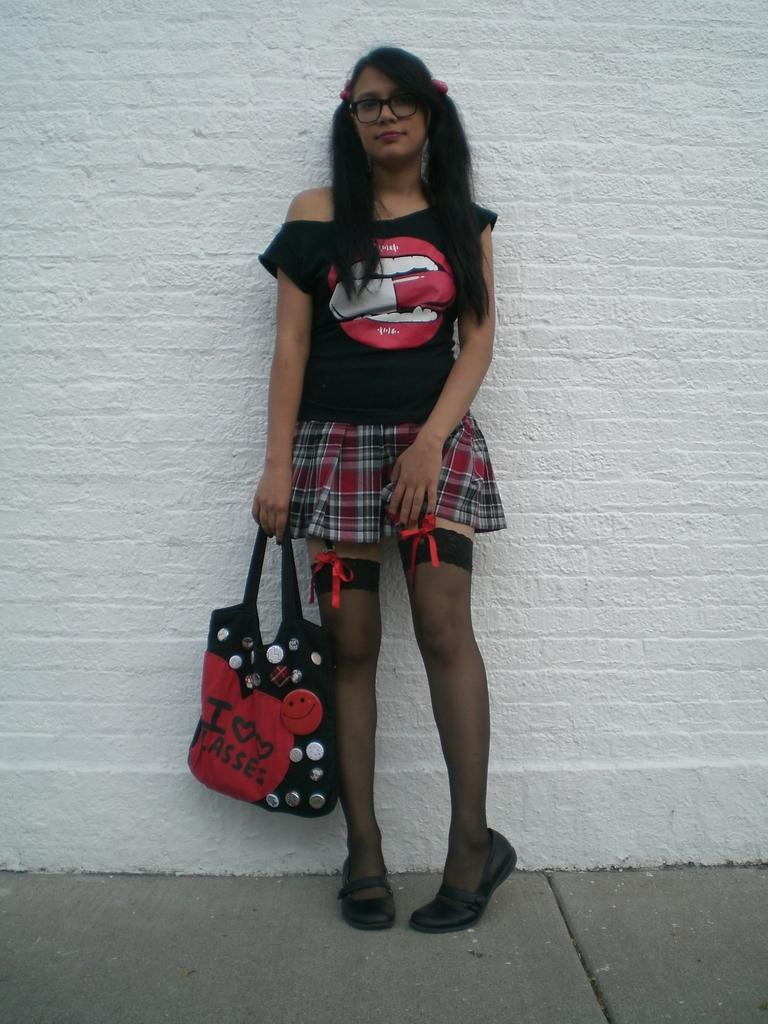What is the main subject of the image? There is a person standing in the image. What is the person holding in the image? The person is holding a bag. What can be seen in the background of the image? There is a wall in the background of the image. What type of bear can be seen interacting with the person in the image? There is no bear present in the image; it only features a person standing and holding a bag. What kind of ray is visible on the wall in the background of the image? There is no ray visible on the wall in the background of the image; it only features a person standing and holding a bag, with a wall in the background. 